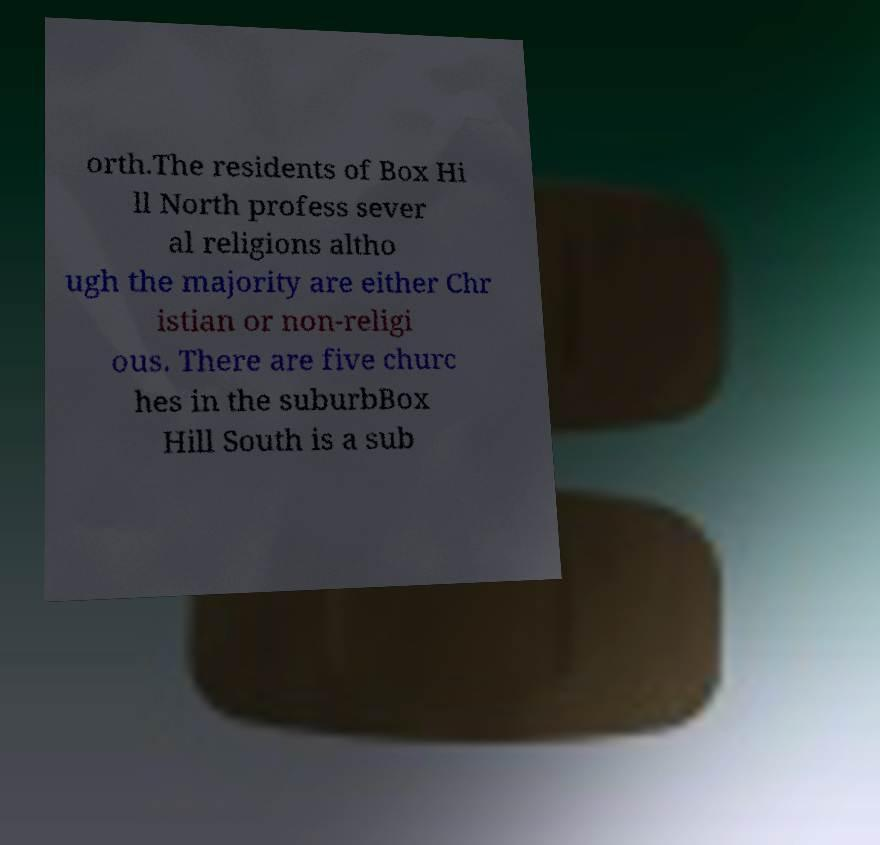Can you accurately transcribe the text from the provided image for me? orth.The residents of Box Hi ll North profess sever al religions altho ugh the majority are either Chr istian or non-religi ous. There are five churc hes in the suburbBox Hill South is a sub 